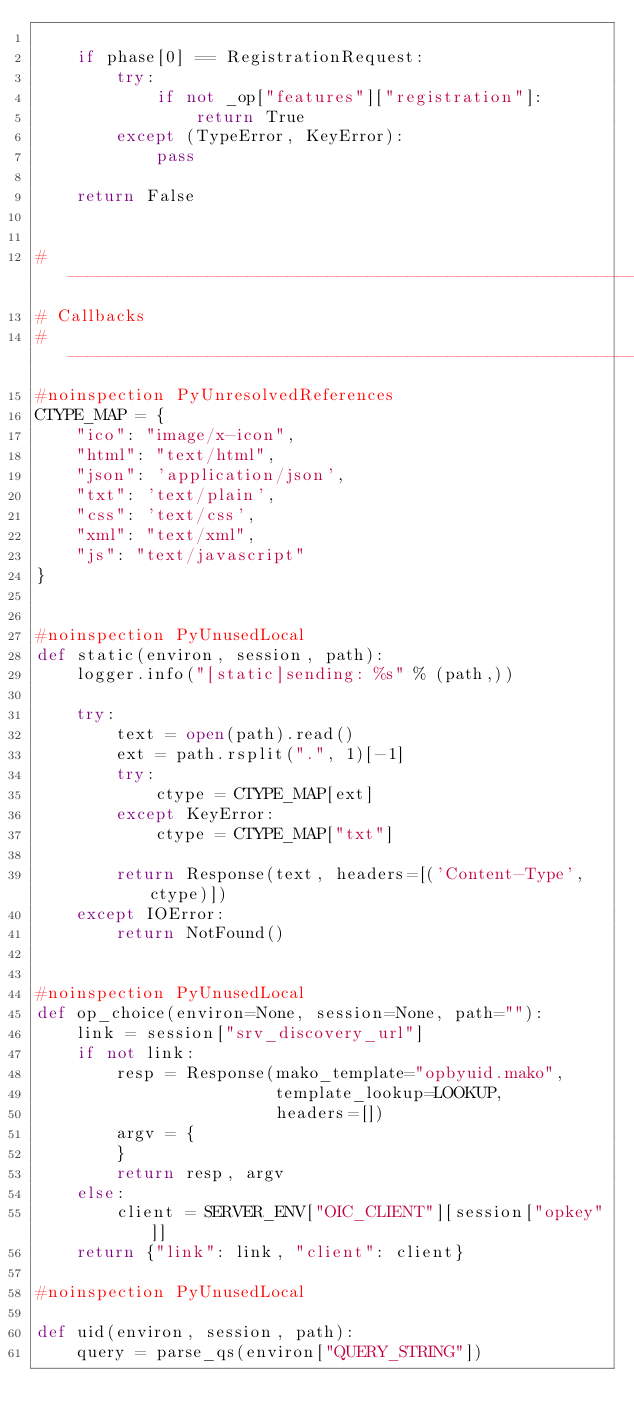<code> <loc_0><loc_0><loc_500><loc_500><_Python_>
    if phase[0] == RegistrationRequest:
        try:
            if not _op["features"]["registration"]:
                return True
        except (TypeError, KeyError):
            pass

    return False


# -----------------------------------------------------------------------------
# Callbacks
# -----------------------------------------------------------------------------
#noinspection PyUnresolvedReferences
CTYPE_MAP = {
    "ico": "image/x-icon",
    "html": "text/html",
    "json": 'application/json',
    "txt": 'text/plain',
    "css": 'text/css',
    "xml": "text/xml",
    "js": "text/javascript"
}


#noinspection PyUnusedLocal
def static(environ, session, path):
    logger.info("[static]sending: %s" % (path,))

    try:
        text = open(path).read()
        ext = path.rsplit(".", 1)[-1]
        try:
            ctype = CTYPE_MAP[ext]
        except KeyError:
            ctype = CTYPE_MAP["txt"]

        return Response(text, headers=[('Content-Type', ctype)])
    except IOError:
        return NotFound()


#noinspection PyUnusedLocal
def op_choice(environ=None, session=None, path=""):
    link = session["srv_discovery_url"]
    if not link:
        resp = Response(mako_template="opbyuid.mako",
                        template_lookup=LOOKUP,
                        headers=[])
        argv = {
        }
        return resp, argv
    else:
        client = SERVER_ENV["OIC_CLIENT"][session["opkey"]]
    return {"link": link, "client": client}

#noinspection PyUnusedLocal

def uid(environ, session, path):
    query = parse_qs(environ["QUERY_STRING"])</code> 